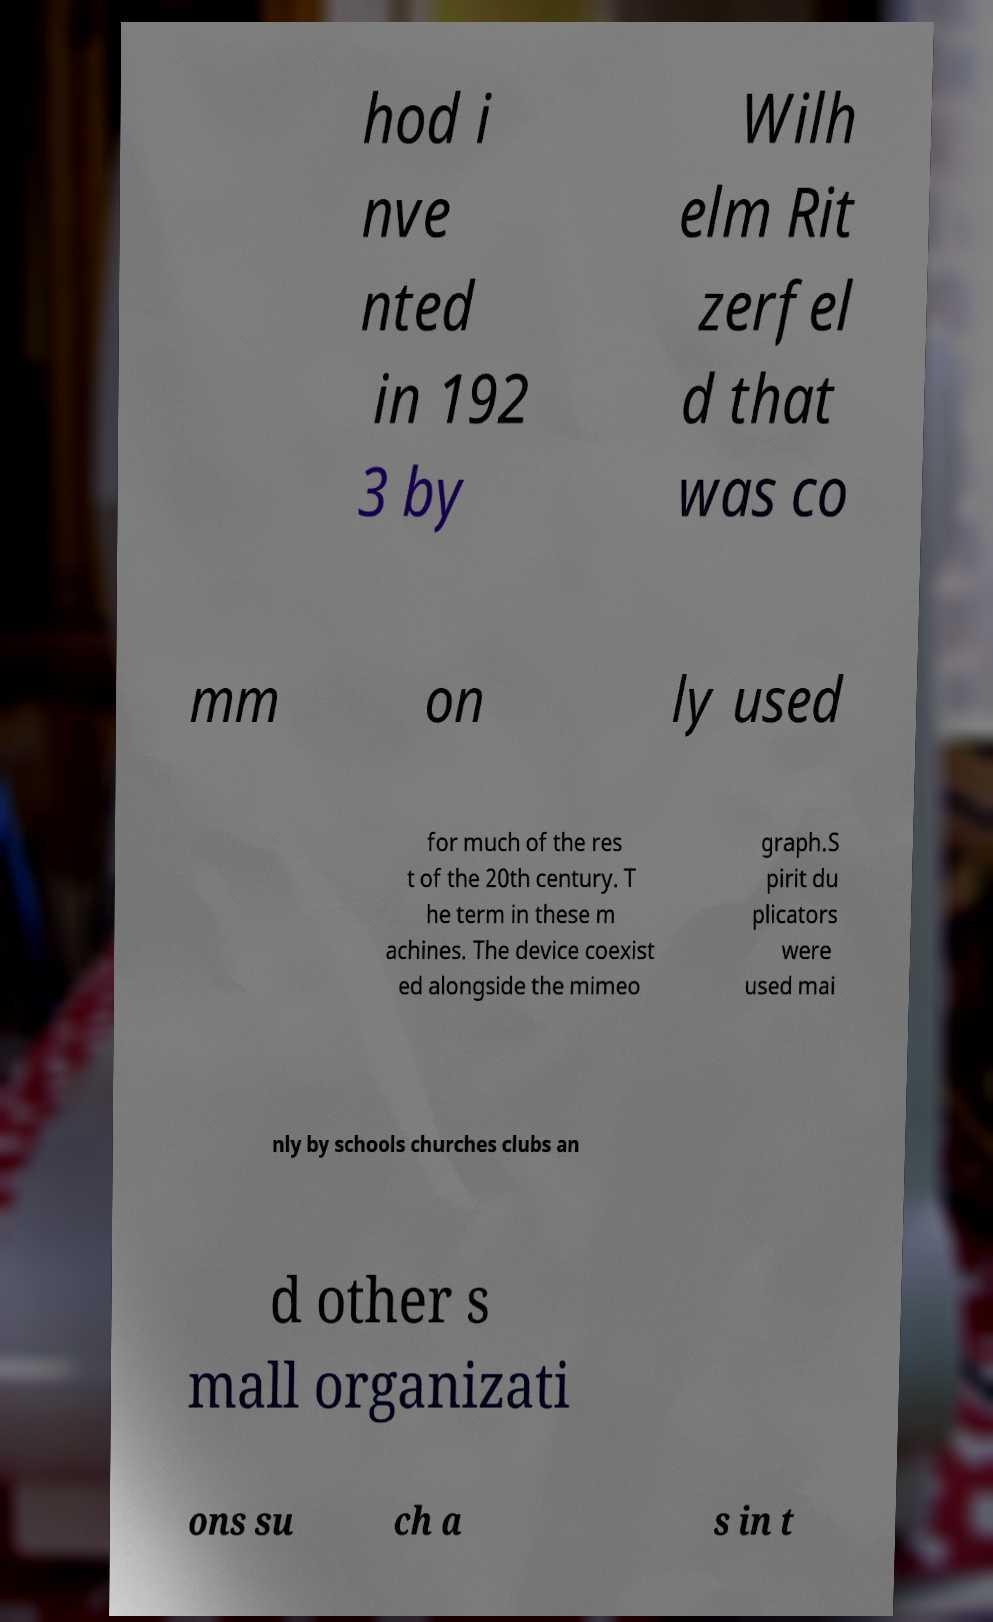I need the written content from this picture converted into text. Can you do that? hod i nve nted in 192 3 by Wilh elm Rit zerfel d that was co mm on ly used for much of the res t of the 20th century. T he term in these m achines. The device coexist ed alongside the mimeo graph.S pirit du plicators were used mai nly by schools churches clubs an d other s mall organizati ons su ch a s in t 